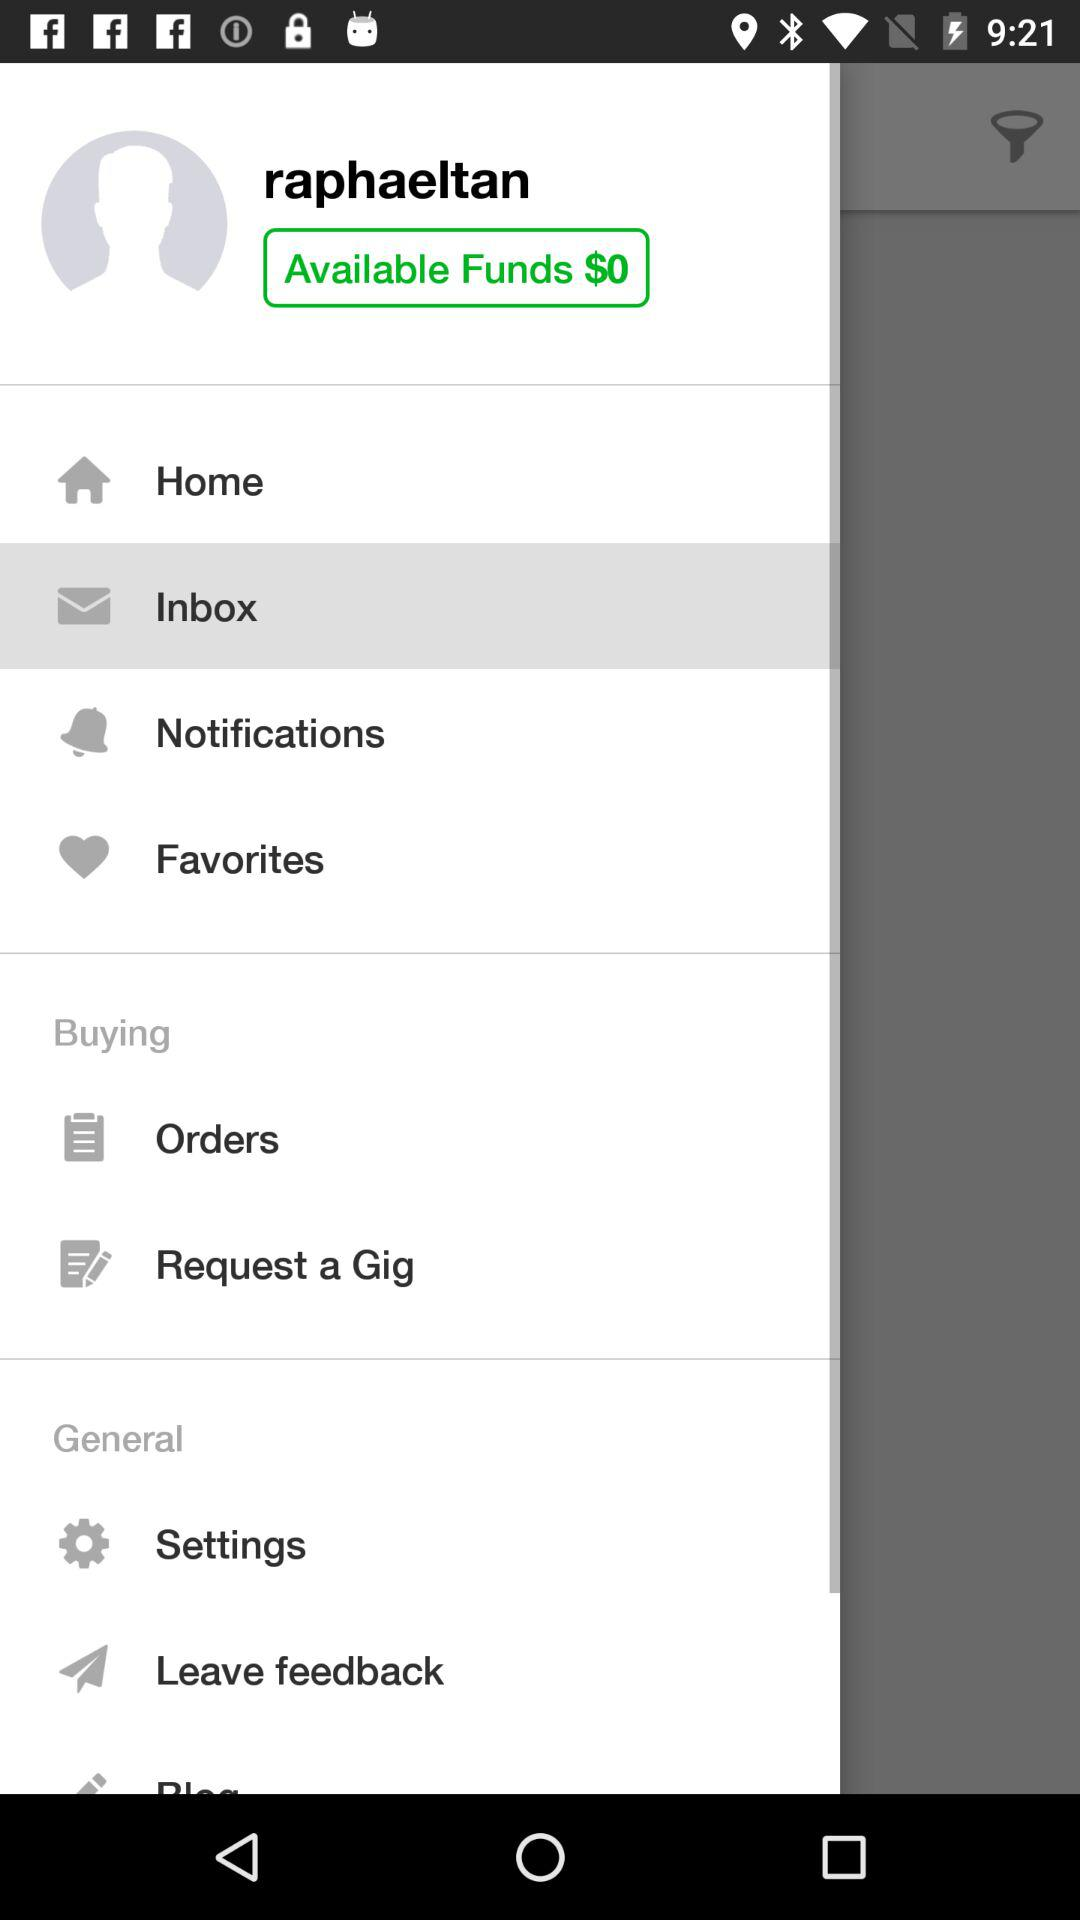How many funds are available? The available fund is $0. 